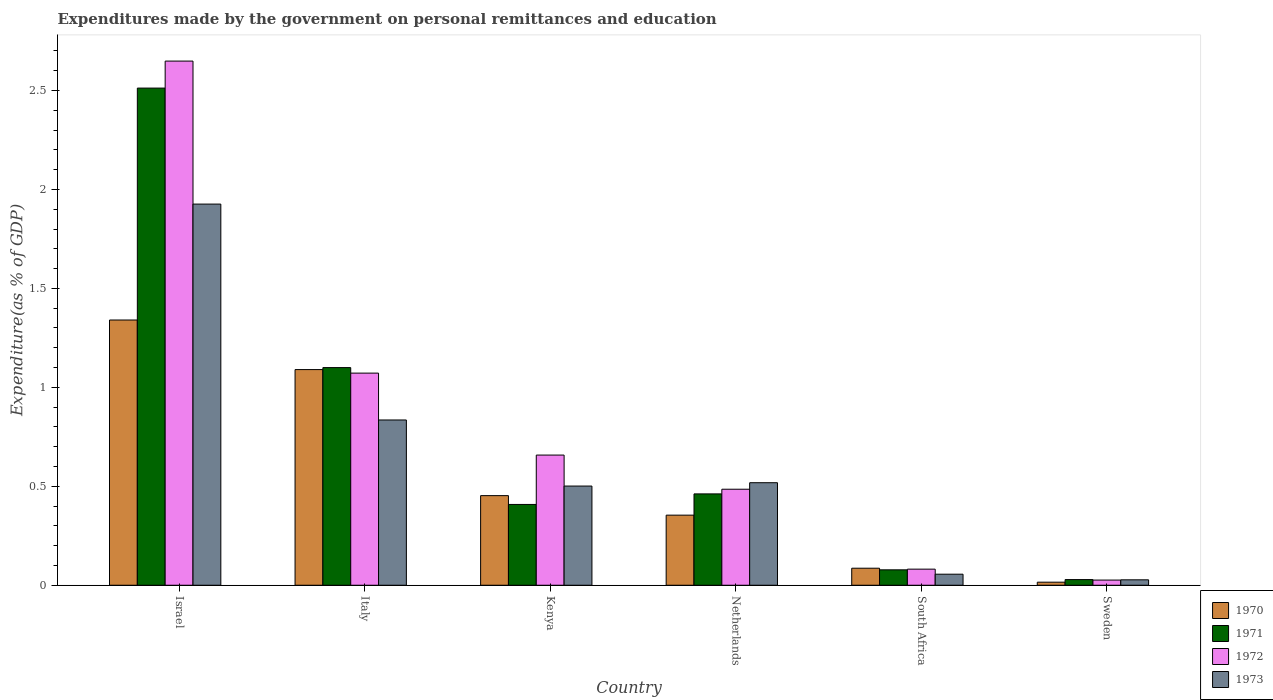How many different coloured bars are there?
Your answer should be very brief. 4. Are the number of bars on each tick of the X-axis equal?
Offer a very short reply. Yes. What is the label of the 5th group of bars from the left?
Give a very brief answer. South Africa. In how many cases, is the number of bars for a given country not equal to the number of legend labels?
Make the answer very short. 0. What is the expenditures made by the government on personal remittances and education in 1972 in Israel?
Your response must be concise. 2.65. Across all countries, what is the maximum expenditures made by the government on personal remittances and education in 1971?
Give a very brief answer. 2.51. Across all countries, what is the minimum expenditures made by the government on personal remittances and education in 1971?
Your answer should be very brief. 0.03. In which country was the expenditures made by the government on personal remittances and education in 1973 maximum?
Keep it short and to the point. Israel. What is the total expenditures made by the government on personal remittances and education in 1971 in the graph?
Keep it short and to the point. 4.59. What is the difference between the expenditures made by the government on personal remittances and education in 1973 in Israel and that in Sweden?
Ensure brevity in your answer.  1.9. What is the difference between the expenditures made by the government on personal remittances and education in 1973 in Netherlands and the expenditures made by the government on personal remittances and education in 1971 in Italy?
Your response must be concise. -0.58. What is the average expenditures made by the government on personal remittances and education in 1972 per country?
Provide a succinct answer. 0.83. What is the difference between the expenditures made by the government on personal remittances and education of/in 1972 and expenditures made by the government on personal remittances and education of/in 1971 in Israel?
Keep it short and to the point. 0.14. What is the ratio of the expenditures made by the government on personal remittances and education in 1970 in Italy to that in Netherlands?
Ensure brevity in your answer.  3.08. What is the difference between the highest and the second highest expenditures made by the government on personal remittances and education in 1973?
Give a very brief answer. -1.09. What is the difference between the highest and the lowest expenditures made by the government on personal remittances and education in 1972?
Your response must be concise. 2.62. In how many countries, is the expenditures made by the government on personal remittances and education in 1972 greater than the average expenditures made by the government on personal remittances and education in 1972 taken over all countries?
Offer a terse response. 2. Is the sum of the expenditures made by the government on personal remittances and education in 1973 in Israel and Italy greater than the maximum expenditures made by the government on personal remittances and education in 1970 across all countries?
Offer a terse response. Yes. What does the 3rd bar from the right in Netherlands represents?
Your response must be concise. 1971. Is it the case that in every country, the sum of the expenditures made by the government on personal remittances and education in 1970 and expenditures made by the government on personal remittances and education in 1971 is greater than the expenditures made by the government on personal remittances and education in 1973?
Offer a very short reply. Yes. How many countries are there in the graph?
Offer a terse response. 6. Does the graph contain any zero values?
Give a very brief answer. No. Where does the legend appear in the graph?
Give a very brief answer. Bottom right. How are the legend labels stacked?
Your answer should be very brief. Vertical. What is the title of the graph?
Your answer should be compact. Expenditures made by the government on personal remittances and education. What is the label or title of the Y-axis?
Ensure brevity in your answer.  Expenditure(as % of GDP). What is the Expenditure(as % of GDP) in 1970 in Israel?
Offer a very short reply. 1.34. What is the Expenditure(as % of GDP) in 1971 in Israel?
Offer a very short reply. 2.51. What is the Expenditure(as % of GDP) of 1972 in Israel?
Provide a short and direct response. 2.65. What is the Expenditure(as % of GDP) of 1973 in Israel?
Offer a terse response. 1.93. What is the Expenditure(as % of GDP) of 1970 in Italy?
Give a very brief answer. 1.09. What is the Expenditure(as % of GDP) of 1971 in Italy?
Provide a succinct answer. 1.1. What is the Expenditure(as % of GDP) of 1972 in Italy?
Offer a very short reply. 1.07. What is the Expenditure(as % of GDP) in 1973 in Italy?
Offer a terse response. 0.84. What is the Expenditure(as % of GDP) in 1970 in Kenya?
Ensure brevity in your answer.  0.45. What is the Expenditure(as % of GDP) in 1971 in Kenya?
Ensure brevity in your answer.  0.41. What is the Expenditure(as % of GDP) in 1972 in Kenya?
Your response must be concise. 0.66. What is the Expenditure(as % of GDP) in 1973 in Kenya?
Give a very brief answer. 0.5. What is the Expenditure(as % of GDP) in 1970 in Netherlands?
Offer a very short reply. 0.35. What is the Expenditure(as % of GDP) in 1971 in Netherlands?
Your answer should be compact. 0.46. What is the Expenditure(as % of GDP) of 1972 in Netherlands?
Offer a very short reply. 0.49. What is the Expenditure(as % of GDP) in 1973 in Netherlands?
Provide a short and direct response. 0.52. What is the Expenditure(as % of GDP) of 1970 in South Africa?
Make the answer very short. 0.09. What is the Expenditure(as % of GDP) in 1971 in South Africa?
Make the answer very short. 0.08. What is the Expenditure(as % of GDP) of 1972 in South Africa?
Ensure brevity in your answer.  0.08. What is the Expenditure(as % of GDP) in 1973 in South Africa?
Provide a succinct answer. 0.06. What is the Expenditure(as % of GDP) in 1970 in Sweden?
Your answer should be compact. 0.02. What is the Expenditure(as % of GDP) in 1971 in Sweden?
Make the answer very short. 0.03. What is the Expenditure(as % of GDP) of 1972 in Sweden?
Ensure brevity in your answer.  0.03. What is the Expenditure(as % of GDP) in 1973 in Sweden?
Provide a succinct answer. 0.03. Across all countries, what is the maximum Expenditure(as % of GDP) of 1970?
Provide a short and direct response. 1.34. Across all countries, what is the maximum Expenditure(as % of GDP) of 1971?
Ensure brevity in your answer.  2.51. Across all countries, what is the maximum Expenditure(as % of GDP) in 1972?
Provide a short and direct response. 2.65. Across all countries, what is the maximum Expenditure(as % of GDP) of 1973?
Make the answer very short. 1.93. Across all countries, what is the minimum Expenditure(as % of GDP) in 1970?
Give a very brief answer. 0.02. Across all countries, what is the minimum Expenditure(as % of GDP) of 1971?
Provide a succinct answer. 0.03. Across all countries, what is the minimum Expenditure(as % of GDP) in 1972?
Give a very brief answer. 0.03. Across all countries, what is the minimum Expenditure(as % of GDP) of 1973?
Ensure brevity in your answer.  0.03. What is the total Expenditure(as % of GDP) of 1970 in the graph?
Offer a very short reply. 3.34. What is the total Expenditure(as % of GDP) of 1971 in the graph?
Give a very brief answer. 4.59. What is the total Expenditure(as % of GDP) in 1972 in the graph?
Your answer should be very brief. 4.97. What is the total Expenditure(as % of GDP) in 1973 in the graph?
Your answer should be very brief. 3.86. What is the difference between the Expenditure(as % of GDP) in 1970 in Israel and that in Italy?
Your answer should be very brief. 0.25. What is the difference between the Expenditure(as % of GDP) in 1971 in Israel and that in Italy?
Provide a succinct answer. 1.41. What is the difference between the Expenditure(as % of GDP) in 1972 in Israel and that in Italy?
Your answer should be very brief. 1.58. What is the difference between the Expenditure(as % of GDP) in 1970 in Israel and that in Kenya?
Provide a short and direct response. 0.89. What is the difference between the Expenditure(as % of GDP) in 1971 in Israel and that in Kenya?
Your answer should be very brief. 2.1. What is the difference between the Expenditure(as % of GDP) of 1972 in Israel and that in Kenya?
Keep it short and to the point. 1.99. What is the difference between the Expenditure(as % of GDP) of 1973 in Israel and that in Kenya?
Your answer should be compact. 1.42. What is the difference between the Expenditure(as % of GDP) in 1970 in Israel and that in Netherlands?
Ensure brevity in your answer.  0.99. What is the difference between the Expenditure(as % of GDP) in 1971 in Israel and that in Netherlands?
Provide a short and direct response. 2.05. What is the difference between the Expenditure(as % of GDP) of 1972 in Israel and that in Netherlands?
Ensure brevity in your answer.  2.16. What is the difference between the Expenditure(as % of GDP) in 1973 in Israel and that in Netherlands?
Make the answer very short. 1.41. What is the difference between the Expenditure(as % of GDP) of 1970 in Israel and that in South Africa?
Keep it short and to the point. 1.25. What is the difference between the Expenditure(as % of GDP) in 1971 in Israel and that in South Africa?
Offer a terse response. 2.43. What is the difference between the Expenditure(as % of GDP) in 1972 in Israel and that in South Africa?
Provide a short and direct response. 2.57. What is the difference between the Expenditure(as % of GDP) of 1973 in Israel and that in South Africa?
Make the answer very short. 1.87. What is the difference between the Expenditure(as % of GDP) in 1970 in Israel and that in Sweden?
Keep it short and to the point. 1.32. What is the difference between the Expenditure(as % of GDP) in 1971 in Israel and that in Sweden?
Your response must be concise. 2.48. What is the difference between the Expenditure(as % of GDP) of 1972 in Israel and that in Sweden?
Your answer should be very brief. 2.62. What is the difference between the Expenditure(as % of GDP) in 1973 in Israel and that in Sweden?
Your answer should be very brief. 1.9. What is the difference between the Expenditure(as % of GDP) in 1970 in Italy and that in Kenya?
Provide a short and direct response. 0.64. What is the difference between the Expenditure(as % of GDP) of 1971 in Italy and that in Kenya?
Provide a short and direct response. 0.69. What is the difference between the Expenditure(as % of GDP) in 1972 in Italy and that in Kenya?
Your answer should be compact. 0.41. What is the difference between the Expenditure(as % of GDP) of 1973 in Italy and that in Kenya?
Make the answer very short. 0.33. What is the difference between the Expenditure(as % of GDP) in 1970 in Italy and that in Netherlands?
Provide a short and direct response. 0.74. What is the difference between the Expenditure(as % of GDP) in 1971 in Italy and that in Netherlands?
Make the answer very short. 0.64. What is the difference between the Expenditure(as % of GDP) of 1972 in Italy and that in Netherlands?
Keep it short and to the point. 0.59. What is the difference between the Expenditure(as % of GDP) of 1973 in Italy and that in Netherlands?
Give a very brief answer. 0.32. What is the difference between the Expenditure(as % of GDP) of 1971 in Italy and that in South Africa?
Offer a terse response. 1.02. What is the difference between the Expenditure(as % of GDP) in 1972 in Italy and that in South Africa?
Provide a short and direct response. 0.99. What is the difference between the Expenditure(as % of GDP) in 1973 in Italy and that in South Africa?
Provide a succinct answer. 0.78. What is the difference between the Expenditure(as % of GDP) of 1970 in Italy and that in Sweden?
Your answer should be very brief. 1.07. What is the difference between the Expenditure(as % of GDP) of 1971 in Italy and that in Sweden?
Make the answer very short. 1.07. What is the difference between the Expenditure(as % of GDP) of 1972 in Italy and that in Sweden?
Make the answer very short. 1.05. What is the difference between the Expenditure(as % of GDP) in 1973 in Italy and that in Sweden?
Make the answer very short. 0.81. What is the difference between the Expenditure(as % of GDP) of 1970 in Kenya and that in Netherlands?
Offer a very short reply. 0.1. What is the difference between the Expenditure(as % of GDP) of 1971 in Kenya and that in Netherlands?
Provide a short and direct response. -0.05. What is the difference between the Expenditure(as % of GDP) in 1972 in Kenya and that in Netherlands?
Offer a very short reply. 0.17. What is the difference between the Expenditure(as % of GDP) of 1973 in Kenya and that in Netherlands?
Offer a very short reply. -0.02. What is the difference between the Expenditure(as % of GDP) in 1970 in Kenya and that in South Africa?
Offer a terse response. 0.37. What is the difference between the Expenditure(as % of GDP) in 1971 in Kenya and that in South Africa?
Provide a short and direct response. 0.33. What is the difference between the Expenditure(as % of GDP) of 1972 in Kenya and that in South Africa?
Your response must be concise. 0.58. What is the difference between the Expenditure(as % of GDP) of 1973 in Kenya and that in South Africa?
Your answer should be compact. 0.45. What is the difference between the Expenditure(as % of GDP) of 1970 in Kenya and that in Sweden?
Keep it short and to the point. 0.44. What is the difference between the Expenditure(as % of GDP) of 1971 in Kenya and that in Sweden?
Offer a very short reply. 0.38. What is the difference between the Expenditure(as % of GDP) of 1972 in Kenya and that in Sweden?
Your response must be concise. 0.63. What is the difference between the Expenditure(as % of GDP) of 1973 in Kenya and that in Sweden?
Your response must be concise. 0.47. What is the difference between the Expenditure(as % of GDP) in 1970 in Netherlands and that in South Africa?
Make the answer very short. 0.27. What is the difference between the Expenditure(as % of GDP) of 1971 in Netherlands and that in South Africa?
Your answer should be very brief. 0.38. What is the difference between the Expenditure(as % of GDP) in 1972 in Netherlands and that in South Africa?
Offer a terse response. 0.4. What is the difference between the Expenditure(as % of GDP) in 1973 in Netherlands and that in South Africa?
Your answer should be very brief. 0.46. What is the difference between the Expenditure(as % of GDP) in 1970 in Netherlands and that in Sweden?
Give a very brief answer. 0.34. What is the difference between the Expenditure(as % of GDP) of 1971 in Netherlands and that in Sweden?
Offer a very short reply. 0.43. What is the difference between the Expenditure(as % of GDP) in 1972 in Netherlands and that in Sweden?
Provide a short and direct response. 0.46. What is the difference between the Expenditure(as % of GDP) of 1973 in Netherlands and that in Sweden?
Provide a succinct answer. 0.49. What is the difference between the Expenditure(as % of GDP) in 1970 in South Africa and that in Sweden?
Your answer should be very brief. 0.07. What is the difference between the Expenditure(as % of GDP) of 1971 in South Africa and that in Sweden?
Give a very brief answer. 0.05. What is the difference between the Expenditure(as % of GDP) in 1972 in South Africa and that in Sweden?
Give a very brief answer. 0.06. What is the difference between the Expenditure(as % of GDP) in 1973 in South Africa and that in Sweden?
Offer a very short reply. 0.03. What is the difference between the Expenditure(as % of GDP) in 1970 in Israel and the Expenditure(as % of GDP) in 1971 in Italy?
Make the answer very short. 0.24. What is the difference between the Expenditure(as % of GDP) of 1970 in Israel and the Expenditure(as % of GDP) of 1972 in Italy?
Your answer should be very brief. 0.27. What is the difference between the Expenditure(as % of GDP) of 1970 in Israel and the Expenditure(as % of GDP) of 1973 in Italy?
Make the answer very short. 0.51. What is the difference between the Expenditure(as % of GDP) of 1971 in Israel and the Expenditure(as % of GDP) of 1972 in Italy?
Make the answer very short. 1.44. What is the difference between the Expenditure(as % of GDP) in 1971 in Israel and the Expenditure(as % of GDP) in 1973 in Italy?
Offer a very short reply. 1.68. What is the difference between the Expenditure(as % of GDP) of 1972 in Israel and the Expenditure(as % of GDP) of 1973 in Italy?
Your response must be concise. 1.81. What is the difference between the Expenditure(as % of GDP) of 1970 in Israel and the Expenditure(as % of GDP) of 1971 in Kenya?
Offer a very short reply. 0.93. What is the difference between the Expenditure(as % of GDP) of 1970 in Israel and the Expenditure(as % of GDP) of 1972 in Kenya?
Make the answer very short. 0.68. What is the difference between the Expenditure(as % of GDP) of 1970 in Israel and the Expenditure(as % of GDP) of 1973 in Kenya?
Make the answer very short. 0.84. What is the difference between the Expenditure(as % of GDP) of 1971 in Israel and the Expenditure(as % of GDP) of 1972 in Kenya?
Offer a terse response. 1.85. What is the difference between the Expenditure(as % of GDP) in 1971 in Israel and the Expenditure(as % of GDP) in 1973 in Kenya?
Provide a short and direct response. 2.01. What is the difference between the Expenditure(as % of GDP) of 1972 in Israel and the Expenditure(as % of GDP) of 1973 in Kenya?
Your answer should be compact. 2.15. What is the difference between the Expenditure(as % of GDP) in 1970 in Israel and the Expenditure(as % of GDP) in 1971 in Netherlands?
Ensure brevity in your answer.  0.88. What is the difference between the Expenditure(as % of GDP) of 1970 in Israel and the Expenditure(as % of GDP) of 1972 in Netherlands?
Your answer should be very brief. 0.85. What is the difference between the Expenditure(as % of GDP) of 1970 in Israel and the Expenditure(as % of GDP) of 1973 in Netherlands?
Provide a short and direct response. 0.82. What is the difference between the Expenditure(as % of GDP) in 1971 in Israel and the Expenditure(as % of GDP) in 1972 in Netherlands?
Make the answer very short. 2.03. What is the difference between the Expenditure(as % of GDP) in 1971 in Israel and the Expenditure(as % of GDP) in 1973 in Netherlands?
Your answer should be very brief. 1.99. What is the difference between the Expenditure(as % of GDP) of 1972 in Israel and the Expenditure(as % of GDP) of 1973 in Netherlands?
Provide a succinct answer. 2.13. What is the difference between the Expenditure(as % of GDP) of 1970 in Israel and the Expenditure(as % of GDP) of 1971 in South Africa?
Offer a terse response. 1.26. What is the difference between the Expenditure(as % of GDP) of 1970 in Israel and the Expenditure(as % of GDP) of 1972 in South Africa?
Keep it short and to the point. 1.26. What is the difference between the Expenditure(as % of GDP) of 1970 in Israel and the Expenditure(as % of GDP) of 1973 in South Africa?
Your answer should be compact. 1.28. What is the difference between the Expenditure(as % of GDP) in 1971 in Israel and the Expenditure(as % of GDP) in 1972 in South Africa?
Offer a terse response. 2.43. What is the difference between the Expenditure(as % of GDP) in 1971 in Israel and the Expenditure(as % of GDP) in 1973 in South Africa?
Your response must be concise. 2.46. What is the difference between the Expenditure(as % of GDP) of 1972 in Israel and the Expenditure(as % of GDP) of 1973 in South Africa?
Provide a short and direct response. 2.59. What is the difference between the Expenditure(as % of GDP) of 1970 in Israel and the Expenditure(as % of GDP) of 1971 in Sweden?
Your answer should be very brief. 1.31. What is the difference between the Expenditure(as % of GDP) in 1970 in Israel and the Expenditure(as % of GDP) in 1972 in Sweden?
Give a very brief answer. 1.31. What is the difference between the Expenditure(as % of GDP) of 1970 in Israel and the Expenditure(as % of GDP) of 1973 in Sweden?
Your answer should be compact. 1.31. What is the difference between the Expenditure(as % of GDP) in 1971 in Israel and the Expenditure(as % of GDP) in 1972 in Sweden?
Your answer should be very brief. 2.49. What is the difference between the Expenditure(as % of GDP) in 1971 in Israel and the Expenditure(as % of GDP) in 1973 in Sweden?
Offer a terse response. 2.48. What is the difference between the Expenditure(as % of GDP) in 1972 in Israel and the Expenditure(as % of GDP) in 1973 in Sweden?
Provide a succinct answer. 2.62. What is the difference between the Expenditure(as % of GDP) of 1970 in Italy and the Expenditure(as % of GDP) of 1971 in Kenya?
Offer a terse response. 0.68. What is the difference between the Expenditure(as % of GDP) of 1970 in Italy and the Expenditure(as % of GDP) of 1972 in Kenya?
Give a very brief answer. 0.43. What is the difference between the Expenditure(as % of GDP) of 1970 in Italy and the Expenditure(as % of GDP) of 1973 in Kenya?
Offer a very short reply. 0.59. What is the difference between the Expenditure(as % of GDP) in 1971 in Italy and the Expenditure(as % of GDP) in 1972 in Kenya?
Your answer should be very brief. 0.44. What is the difference between the Expenditure(as % of GDP) of 1971 in Italy and the Expenditure(as % of GDP) of 1973 in Kenya?
Your answer should be very brief. 0.6. What is the difference between the Expenditure(as % of GDP) in 1972 in Italy and the Expenditure(as % of GDP) in 1973 in Kenya?
Make the answer very short. 0.57. What is the difference between the Expenditure(as % of GDP) of 1970 in Italy and the Expenditure(as % of GDP) of 1971 in Netherlands?
Offer a very short reply. 0.63. What is the difference between the Expenditure(as % of GDP) in 1970 in Italy and the Expenditure(as % of GDP) in 1972 in Netherlands?
Your answer should be very brief. 0.6. What is the difference between the Expenditure(as % of GDP) of 1970 in Italy and the Expenditure(as % of GDP) of 1973 in Netherlands?
Provide a short and direct response. 0.57. What is the difference between the Expenditure(as % of GDP) of 1971 in Italy and the Expenditure(as % of GDP) of 1972 in Netherlands?
Your response must be concise. 0.61. What is the difference between the Expenditure(as % of GDP) of 1971 in Italy and the Expenditure(as % of GDP) of 1973 in Netherlands?
Offer a terse response. 0.58. What is the difference between the Expenditure(as % of GDP) of 1972 in Italy and the Expenditure(as % of GDP) of 1973 in Netherlands?
Offer a terse response. 0.55. What is the difference between the Expenditure(as % of GDP) in 1970 in Italy and the Expenditure(as % of GDP) in 1971 in South Africa?
Offer a very short reply. 1.01. What is the difference between the Expenditure(as % of GDP) in 1970 in Italy and the Expenditure(as % of GDP) in 1972 in South Africa?
Your answer should be very brief. 1.01. What is the difference between the Expenditure(as % of GDP) of 1970 in Italy and the Expenditure(as % of GDP) of 1973 in South Africa?
Make the answer very short. 1.03. What is the difference between the Expenditure(as % of GDP) of 1971 in Italy and the Expenditure(as % of GDP) of 1972 in South Africa?
Ensure brevity in your answer.  1.02. What is the difference between the Expenditure(as % of GDP) in 1971 in Italy and the Expenditure(as % of GDP) in 1973 in South Africa?
Make the answer very short. 1.04. What is the difference between the Expenditure(as % of GDP) in 1970 in Italy and the Expenditure(as % of GDP) in 1971 in Sweden?
Provide a short and direct response. 1.06. What is the difference between the Expenditure(as % of GDP) of 1970 in Italy and the Expenditure(as % of GDP) of 1972 in Sweden?
Give a very brief answer. 1.06. What is the difference between the Expenditure(as % of GDP) of 1970 in Italy and the Expenditure(as % of GDP) of 1973 in Sweden?
Ensure brevity in your answer.  1.06. What is the difference between the Expenditure(as % of GDP) of 1971 in Italy and the Expenditure(as % of GDP) of 1972 in Sweden?
Offer a terse response. 1.07. What is the difference between the Expenditure(as % of GDP) in 1971 in Italy and the Expenditure(as % of GDP) in 1973 in Sweden?
Offer a terse response. 1.07. What is the difference between the Expenditure(as % of GDP) in 1972 in Italy and the Expenditure(as % of GDP) in 1973 in Sweden?
Keep it short and to the point. 1.04. What is the difference between the Expenditure(as % of GDP) of 1970 in Kenya and the Expenditure(as % of GDP) of 1971 in Netherlands?
Ensure brevity in your answer.  -0.01. What is the difference between the Expenditure(as % of GDP) in 1970 in Kenya and the Expenditure(as % of GDP) in 1972 in Netherlands?
Your answer should be very brief. -0.03. What is the difference between the Expenditure(as % of GDP) of 1970 in Kenya and the Expenditure(as % of GDP) of 1973 in Netherlands?
Your response must be concise. -0.07. What is the difference between the Expenditure(as % of GDP) of 1971 in Kenya and the Expenditure(as % of GDP) of 1972 in Netherlands?
Offer a very short reply. -0.08. What is the difference between the Expenditure(as % of GDP) of 1971 in Kenya and the Expenditure(as % of GDP) of 1973 in Netherlands?
Your response must be concise. -0.11. What is the difference between the Expenditure(as % of GDP) in 1972 in Kenya and the Expenditure(as % of GDP) in 1973 in Netherlands?
Provide a short and direct response. 0.14. What is the difference between the Expenditure(as % of GDP) of 1970 in Kenya and the Expenditure(as % of GDP) of 1972 in South Africa?
Keep it short and to the point. 0.37. What is the difference between the Expenditure(as % of GDP) in 1970 in Kenya and the Expenditure(as % of GDP) in 1973 in South Africa?
Keep it short and to the point. 0.4. What is the difference between the Expenditure(as % of GDP) in 1971 in Kenya and the Expenditure(as % of GDP) in 1972 in South Africa?
Give a very brief answer. 0.33. What is the difference between the Expenditure(as % of GDP) in 1971 in Kenya and the Expenditure(as % of GDP) in 1973 in South Africa?
Provide a short and direct response. 0.35. What is the difference between the Expenditure(as % of GDP) in 1972 in Kenya and the Expenditure(as % of GDP) in 1973 in South Africa?
Provide a short and direct response. 0.6. What is the difference between the Expenditure(as % of GDP) in 1970 in Kenya and the Expenditure(as % of GDP) in 1971 in Sweden?
Offer a very short reply. 0.42. What is the difference between the Expenditure(as % of GDP) in 1970 in Kenya and the Expenditure(as % of GDP) in 1972 in Sweden?
Give a very brief answer. 0.43. What is the difference between the Expenditure(as % of GDP) in 1970 in Kenya and the Expenditure(as % of GDP) in 1973 in Sweden?
Your answer should be very brief. 0.43. What is the difference between the Expenditure(as % of GDP) of 1971 in Kenya and the Expenditure(as % of GDP) of 1972 in Sweden?
Give a very brief answer. 0.38. What is the difference between the Expenditure(as % of GDP) in 1971 in Kenya and the Expenditure(as % of GDP) in 1973 in Sweden?
Keep it short and to the point. 0.38. What is the difference between the Expenditure(as % of GDP) in 1972 in Kenya and the Expenditure(as % of GDP) in 1973 in Sweden?
Your response must be concise. 0.63. What is the difference between the Expenditure(as % of GDP) in 1970 in Netherlands and the Expenditure(as % of GDP) in 1971 in South Africa?
Keep it short and to the point. 0.28. What is the difference between the Expenditure(as % of GDP) in 1970 in Netherlands and the Expenditure(as % of GDP) in 1972 in South Africa?
Offer a very short reply. 0.27. What is the difference between the Expenditure(as % of GDP) in 1970 in Netherlands and the Expenditure(as % of GDP) in 1973 in South Africa?
Offer a very short reply. 0.3. What is the difference between the Expenditure(as % of GDP) of 1971 in Netherlands and the Expenditure(as % of GDP) of 1972 in South Africa?
Give a very brief answer. 0.38. What is the difference between the Expenditure(as % of GDP) of 1971 in Netherlands and the Expenditure(as % of GDP) of 1973 in South Africa?
Your answer should be compact. 0.41. What is the difference between the Expenditure(as % of GDP) in 1972 in Netherlands and the Expenditure(as % of GDP) in 1973 in South Africa?
Offer a terse response. 0.43. What is the difference between the Expenditure(as % of GDP) of 1970 in Netherlands and the Expenditure(as % of GDP) of 1971 in Sweden?
Your answer should be very brief. 0.33. What is the difference between the Expenditure(as % of GDP) of 1970 in Netherlands and the Expenditure(as % of GDP) of 1972 in Sweden?
Your answer should be very brief. 0.33. What is the difference between the Expenditure(as % of GDP) in 1970 in Netherlands and the Expenditure(as % of GDP) in 1973 in Sweden?
Offer a very short reply. 0.33. What is the difference between the Expenditure(as % of GDP) in 1971 in Netherlands and the Expenditure(as % of GDP) in 1972 in Sweden?
Give a very brief answer. 0.44. What is the difference between the Expenditure(as % of GDP) of 1971 in Netherlands and the Expenditure(as % of GDP) of 1973 in Sweden?
Keep it short and to the point. 0.43. What is the difference between the Expenditure(as % of GDP) in 1972 in Netherlands and the Expenditure(as % of GDP) in 1973 in Sweden?
Keep it short and to the point. 0.46. What is the difference between the Expenditure(as % of GDP) of 1970 in South Africa and the Expenditure(as % of GDP) of 1971 in Sweden?
Your answer should be very brief. 0.06. What is the difference between the Expenditure(as % of GDP) in 1970 in South Africa and the Expenditure(as % of GDP) in 1972 in Sweden?
Keep it short and to the point. 0.06. What is the difference between the Expenditure(as % of GDP) in 1970 in South Africa and the Expenditure(as % of GDP) in 1973 in Sweden?
Your answer should be very brief. 0.06. What is the difference between the Expenditure(as % of GDP) of 1971 in South Africa and the Expenditure(as % of GDP) of 1972 in Sweden?
Your answer should be very brief. 0.05. What is the difference between the Expenditure(as % of GDP) of 1971 in South Africa and the Expenditure(as % of GDP) of 1973 in Sweden?
Your answer should be compact. 0.05. What is the difference between the Expenditure(as % of GDP) in 1972 in South Africa and the Expenditure(as % of GDP) in 1973 in Sweden?
Offer a terse response. 0.05. What is the average Expenditure(as % of GDP) in 1970 per country?
Offer a terse response. 0.56. What is the average Expenditure(as % of GDP) of 1971 per country?
Offer a terse response. 0.76. What is the average Expenditure(as % of GDP) of 1972 per country?
Provide a short and direct response. 0.83. What is the average Expenditure(as % of GDP) of 1973 per country?
Offer a very short reply. 0.64. What is the difference between the Expenditure(as % of GDP) of 1970 and Expenditure(as % of GDP) of 1971 in Israel?
Keep it short and to the point. -1.17. What is the difference between the Expenditure(as % of GDP) of 1970 and Expenditure(as % of GDP) of 1972 in Israel?
Give a very brief answer. -1.31. What is the difference between the Expenditure(as % of GDP) in 1970 and Expenditure(as % of GDP) in 1973 in Israel?
Give a very brief answer. -0.59. What is the difference between the Expenditure(as % of GDP) in 1971 and Expenditure(as % of GDP) in 1972 in Israel?
Your answer should be very brief. -0.14. What is the difference between the Expenditure(as % of GDP) of 1971 and Expenditure(as % of GDP) of 1973 in Israel?
Ensure brevity in your answer.  0.59. What is the difference between the Expenditure(as % of GDP) in 1972 and Expenditure(as % of GDP) in 1973 in Israel?
Your answer should be very brief. 0.72. What is the difference between the Expenditure(as % of GDP) in 1970 and Expenditure(as % of GDP) in 1971 in Italy?
Keep it short and to the point. -0.01. What is the difference between the Expenditure(as % of GDP) of 1970 and Expenditure(as % of GDP) of 1972 in Italy?
Your response must be concise. 0.02. What is the difference between the Expenditure(as % of GDP) of 1970 and Expenditure(as % of GDP) of 1973 in Italy?
Your answer should be compact. 0.25. What is the difference between the Expenditure(as % of GDP) in 1971 and Expenditure(as % of GDP) in 1972 in Italy?
Keep it short and to the point. 0.03. What is the difference between the Expenditure(as % of GDP) of 1971 and Expenditure(as % of GDP) of 1973 in Italy?
Provide a succinct answer. 0.26. What is the difference between the Expenditure(as % of GDP) of 1972 and Expenditure(as % of GDP) of 1973 in Italy?
Your answer should be compact. 0.24. What is the difference between the Expenditure(as % of GDP) in 1970 and Expenditure(as % of GDP) in 1971 in Kenya?
Ensure brevity in your answer.  0.04. What is the difference between the Expenditure(as % of GDP) of 1970 and Expenditure(as % of GDP) of 1972 in Kenya?
Offer a very short reply. -0.2. What is the difference between the Expenditure(as % of GDP) in 1970 and Expenditure(as % of GDP) in 1973 in Kenya?
Keep it short and to the point. -0.05. What is the difference between the Expenditure(as % of GDP) in 1971 and Expenditure(as % of GDP) in 1972 in Kenya?
Offer a terse response. -0.25. What is the difference between the Expenditure(as % of GDP) of 1971 and Expenditure(as % of GDP) of 1973 in Kenya?
Your answer should be compact. -0.09. What is the difference between the Expenditure(as % of GDP) in 1972 and Expenditure(as % of GDP) in 1973 in Kenya?
Keep it short and to the point. 0.16. What is the difference between the Expenditure(as % of GDP) in 1970 and Expenditure(as % of GDP) in 1971 in Netherlands?
Your response must be concise. -0.11. What is the difference between the Expenditure(as % of GDP) of 1970 and Expenditure(as % of GDP) of 1972 in Netherlands?
Your answer should be compact. -0.13. What is the difference between the Expenditure(as % of GDP) in 1970 and Expenditure(as % of GDP) in 1973 in Netherlands?
Keep it short and to the point. -0.16. What is the difference between the Expenditure(as % of GDP) of 1971 and Expenditure(as % of GDP) of 1972 in Netherlands?
Give a very brief answer. -0.02. What is the difference between the Expenditure(as % of GDP) in 1971 and Expenditure(as % of GDP) in 1973 in Netherlands?
Provide a short and direct response. -0.06. What is the difference between the Expenditure(as % of GDP) in 1972 and Expenditure(as % of GDP) in 1973 in Netherlands?
Offer a terse response. -0.03. What is the difference between the Expenditure(as % of GDP) in 1970 and Expenditure(as % of GDP) in 1971 in South Africa?
Offer a very short reply. 0.01. What is the difference between the Expenditure(as % of GDP) of 1970 and Expenditure(as % of GDP) of 1972 in South Africa?
Your answer should be very brief. 0. What is the difference between the Expenditure(as % of GDP) of 1970 and Expenditure(as % of GDP) of 1973 in South Africa?
Offer a terse response. 0.03. What is the difference between the Expenditure(as % of GDP) in 1971 and Expenditure(as % of GDP) in 1972 in South Africa?
Your response must be concise. -0. What is the difference between the Expenditure(as % of GDP) of 1971 and Expenditure(as % of GDP) of 1973 in South Africa?
Ensure brevity in your answer.  0.02. What is the difference between the Expenditure(as % of GDP) in 1972 and Expenditure(as % of GDP) in 1973 in South Africa?
Provide a succinct answer. 0.03. What is the difference between the Expenditure(as % of GDP) of 1970 and Expenditure(as % of GDP) of 1971 in Sweden?
Offer a very short reply. -0.01. What is the difference between the Expenditure(as % of GDP) in 1970 and Expenditure(as % of GDP) in 1972 in Sweden?
Provide a succinct answer. -0.01. What is the difference between the Expenditure(as % of GDP) in 1970 and Expenditure(as % of GDP) in 1973 in Sweden?
Provide a short and direct response. -0.01. What is the difference between the Expenditure(as % of GDP) in 1971 and Expenditure(as % of GDP) in 1972 in Sweden?
Offer a very short reply. 0. What is the difference between the Expenditure(as % of GDP) of 1971 and Expenditure(as % of GDP) of 1973 in Sweden?
Make the answer very short. 0. What is the difference between the Expenditure(as % of GDP) of 1972 and Expenditure(as % of GDP) of 1973 in Sweden?
Your response must be concise. -0. What is the ratio of the Expenditure(as % of GDP) in 1970 in Israel to that in Italy?
Make the answer very short. 1.23. What is the ratio of the Expenditure(as % of GDP) in 1971 in Israel to that in Italy?
Make the answer very short. 2.28. What is the ratio of the Expenditure(as % of GDP) of 1972 in Israel to that in Italy?
Your answer should be very brief. 2.47. What is the ratio of the Expenditure(as % of GDP) in 1973 in Israel to that in Italy?
Your response must be concise. 2.31. What is the ratio of the Expenditure(as % of GDP) of 1970 in Israel to that in Kenya?
Ensure brevity in your answer.  2.96. What is the ratio of the Expenditure(as % of GDP) in 1971 in Israel to that in Kenya?
Make the answer very short. 6.15. What is the ratio of the Expenditure(as % of GDP) of 1972 in Israel to that in Kenya?
Make the answer very short. 4.03. What is the ratio of the Expenditure(as % of GDP) of 1973 in Israel to that in Kenya?
Your answer should be very brief. 3.84. What is the ratio of the Expenditure(as % of GDP) in 1970 in Israel to that in Netherlands?
Keep it short and to the point. 3.78. What is the ratio of the Expenditure(as % of GDP) of 1971 in Israel to that in Netherlands?
Offer a very short reply. 5.44. What is the ratio of the Expenditure(as % of GDP) in 1972 in Israel to that in Netherlands?
Your response must be concise. 5.46. What is the ratio of the Expenditure(as % of GDP) of 1973 in Israel to that in Netherlands?
Your answer should be very brief. 3.72. What is the ratio of the Expenditure(as % of GDP) in 1970 in Israel to that in South Africa?
Make the answer very short. 15.58. What is the ratio of the Expenditure(as % of GDP) of 1971 in Israel to that in South Africa?
Offer a terse response. 32.29. What is the ratio of the Expenditure(as % of GDP) of 1972 in Israel to that in South Africa?
Your response must be concise. 32.58. What is the ratio of the Expenditure(as % of GDP) of 1973 in Israel to that in South Africa?
Provide a short and direct response. 34.5. What is the ratio of the Expenditure(as % of GDP) in 1970 in Israel to that in Sweden?
Keep it short and to the point. 86.79. What is the ratio of the Expenditure(as % of GDP) of 1971 in Israel to that in Sweden?
Provide a short and direct response. 87.95. What is the ratio of the Expenditure(as % of GDP) of 1972 in Israel to that in Sweden?
Offer a very short reply. 101.46. What is the ratio of the Expenditure(as % of GDP) in 1973 in Israel to that in Sweden?
Keep it short and to the point. 70.37. What is the ratio of the Expenditure(as % of GDP) in 1970 in Italy to that in Kenya?
Offer a very short reply. 2.41. What is the ratio of the Expenditure(as % of GDP) of 1971 in Italy to that in Kenya?
Make the answer very short. 2.69. What is the ratio of the Expenditure(as % of GDP) in 1972 in Italy to that in Kenya?
Offer a very short reply. 1.63. What is the ratio of the Expenditure(as % of GDP) of 1973 in Italy to that in Kenya?
Your answer should be very brief. 1.67. What is the ratio of the Expenditure(as % of GDP) of 1970 in Italy to that in Netherlands?
Offer a very short reply. 3.08. What is the ratio of the Expenditure(as % of GDP) in 1971 in Italy to that in Netherlands?
Provide a succinct answer. 2.38. What is the ratio of the Expenditure(as % of GDP) in 1972 in Italy to that in Netherlands?
Keep it short and to the point. 2.21. What is the ratio of the Expenditure(as % of GDP) of 1973 in Italy to that in Netherlands?
Your response must be concise. 1.61. What is the ratio of the Expenditure(as % of GDP) in 1970 in Italy to that in South Africa?
Your answer should be very brief. 12.67. What is the ratio of the Expenditure(as % of GDP) of 1971 in Italy to that in South Africa?
Your answer should be very brief. 14.13. What is the ratio of the Expenditure(as % of GDP) of 1972 in Italy to that in South Africa?
Keep it short and to the point. 13.18. What is the ratio of the Expenditure(as % of GDP) of 1973 in Italy to that in South Africa?
Give a very brief answer. 14.96. What is the ratio of the Expenditure(as % of GDP) of 1970 in Italy to that in Sweden?
Provide a short and direct response. 70.57. What is the ratio of the Expenditure(as % of GDP) of 1971 in Italy to that in Sweden?
Give a very brief answer. 38.5. What is the ratio of the Expenditure(as % of GDP) in 1972 in Italy to that in Sweden?
Provide a succinct answer. 41.06. What is the ratio of the Expenditure(as % of GDP) in 1973 in Italy to that in Sweden?
Your answer should be very brief. 30.51. What is the ratio of the Expenditure(as % of GDP) in 1970 in Kenya to that in Netherlands?
Provide a short and direct response. 1.28. What is the ratio of the Expenditure(as % of GDP) in 1971 in Kenya to that in Netherlands?
Your answer should be very brief. 0.88. What is the ratio of the Expenditure(as % of GDP) of 1972 in Kenya to that in Netherlands?
Offer a very short reply. 1.36. What is the ratio of the Expenditure(as % of GDP) in 1973 in Kenya to that in Netherlands?
Your response must be concise. 0.97. What is the ratio of the Expenditure(as % of GDP) in 1970 in Kenya to that in South Africa?
Your response must be concise. 5.26. What is the ratio of the Expenditure(as % of GDP) of 1971 in Kenya to that in South Africa?
Offer a terse response. 5.25. What is the ratio of the Expenditure(as % of GDP) of 1972 in Kenya to that in South Africa?
Offer a terse response. 8.09. What is the ratio of the Expenditure(as % of GDP) in 1973 in Kenya to that in South Africa?
Provide a short and direct response. 8.98. What is the ratio of the Expenditure(as % of GDP) of 1970 in Kenya to that in Sweden?
Provide a succinct answer. 29.32. What is the ratio of the Expenditure(as % of GDP) of 1971 in Kenya to that in Sweden?
Make the answer very short. 14.29. What is the ratio of the Expenditure(as % of GDP) of 1972 in Kenya to that in Sweden?
Give a very brief answer. 25.2. What is the ratio of the Expenditure(as % of GDP) in 1973 in Kenya to that in Sweden?
Offer a terse response. 18.31. What is the ratio of the Expenditure(as % of GDP) in 1970 in Netherlands to that in South Africa?
Make the answer very short. 4.12. What is the ratio of the Expenditure(as % of GDP) in 1971 in Netherlands to that in South Africa?
Make the answer very short. 5.93. What is the ratio of the Expenditure(as % of GDP) in 1972 in Netherlands to that in South Africa?
Provide a succinct answer. 5.97. What is the ratio of the Expenditure(as % of GDP) in 1973 in Netherlands to that in South Africa?
Your response must be concise. 9.28. What is the ratio of the Expenditure(as % of GDP) in 1970 in Netherlands to that in Sweden?
Your answer should be very brief. 22.93. What is the ratio of the Expenditure(as % of GDP) in 1971 in Netherlands to that in Sweden?
Your answer should be compact. 16.16. What is the ratio of the Expenditure(as % of GDP) in 1972 in Netherlands to that in Sweden?
Your response must be concise. 18.59. What is the ratio of the Expenditure(as % of GDP) of 1973 in Netherlands to that in Sweden?
Ensure brevity in your answer.  18.93. What is the ratio of the Expenditure(as % of GDP) of 1970 in South Africa to that in Sweden?
Ensure brevity in your answer.  5.57. What is the ratio of the Expenditure(as % of GDP) in 1971 in South Africa to that in Sweden?
Ensure brevity in your answer.  2.72. What is the ratio of the Expenditure(as % of GDP) of 1972 in South Africa to that in Sweden?
Make the answer very short. 3.11. What is the ratio of the Expenditure(as % of GDP) of 1973 in South Africa to that in Sweden?
Your answer should be compact. 2.04. What is the difference between the highest and the second highest Expenditure(as % of GDP) of 1970?
Give a very brief answer. 0.25. What is the difference between the highest and the second highest Expenditure(as % of GDP) in 1971?
Offer a very short reply. 1.41. What is the difference between the highest and the second highest Expenditure(as % of GDP) of 1972?
Keep it short and to the point. 1.58. What is the difference between the highest and the second highest Expenditure(as % of GDP) of 1973?
Provide a short and direct response. 1.09. What is the difference between the highest and the lowest Expenditure(as % of GDP) in 1970?
Ensure brevity in your answer.  1.32. What is the difference between the highest and the lowest Expenditure(as % of GDP) of 1971?
Provide a short and direct response. 2.48. What is the difference between the highest and the lowest Expenditure(as % of GDP) of 1972?
Give a very brief answer. 2.62. What is the difference between the highest and the lowest Expenditure(as % of GDP) of 1973?
Your response must be concise. 1.9. 